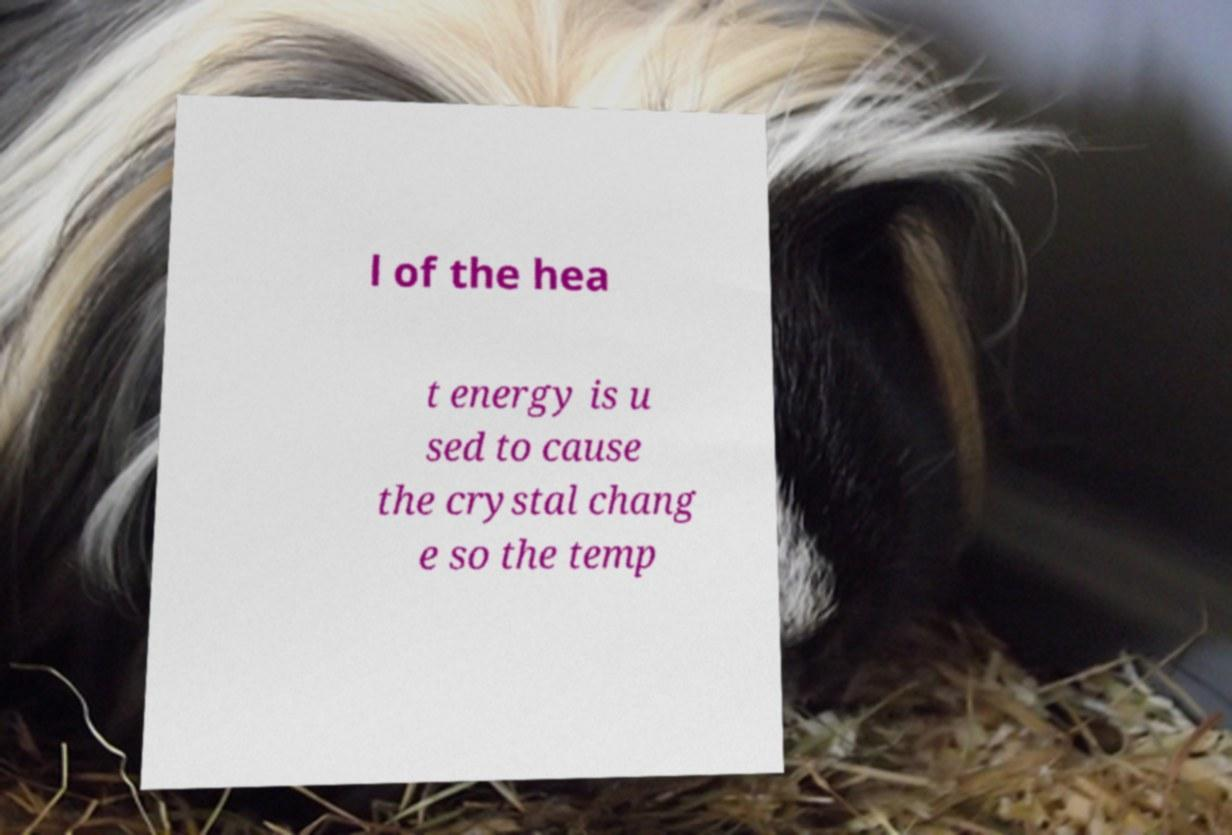Could you extract and type out the text from this image? l of the hea t energy is u sed to cause the crystal chang e so the temp 